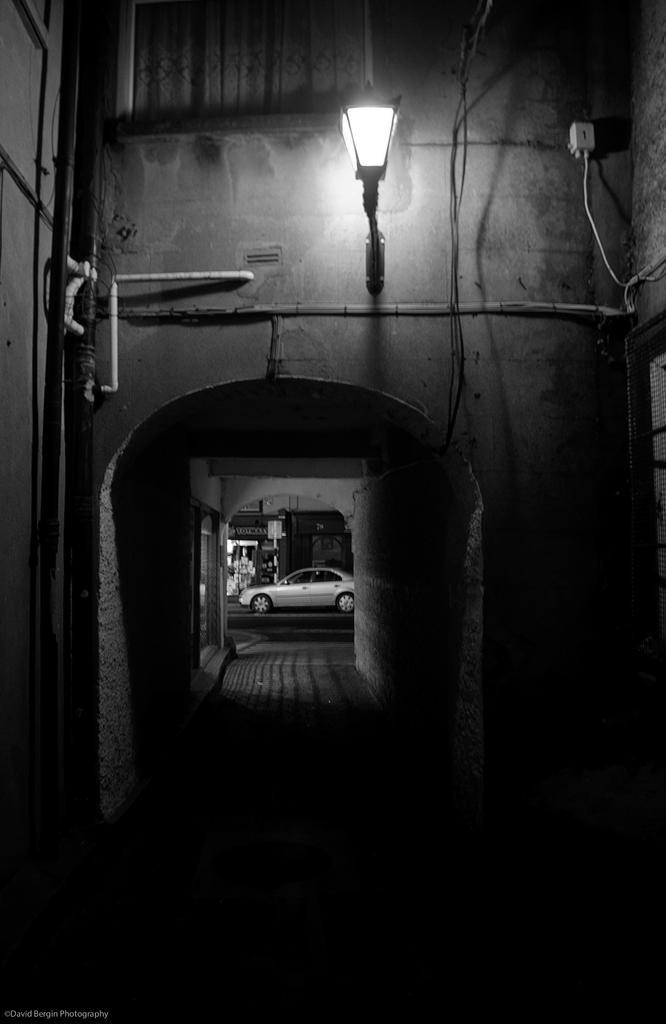Could you give a brief overview of what you see in this image? In this image, we can see a wall, pipes, wires, light and walkway. Background we can see a car on the road, Here there is a shop and hoarding. Top of the image, there is a window, pole, board and curtain. Left side bottom, we can see watermark in the image. 